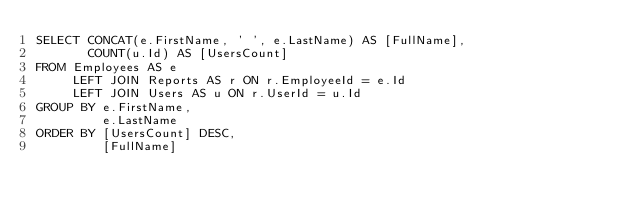Convert code to text. <code><loc_0><loc_0><loc_500><loc_500><_SQL_>SELECT CONCAT(e.FirstName, ' ', e.LastName) AS [FullName], 
       COUNT(u.Id) AS [UsersCount]
FROM Employees AS e
     LEFT JOIN Reports AS r ON r.EmployeeId = e.Id
     LEFT JOIN Users AS u ON r.UserId = u.Id
GROUP BY e.FirstName, 
         e.LastName
ORDER BY [UsersCount] DESC, 
         [FullName]</code> 